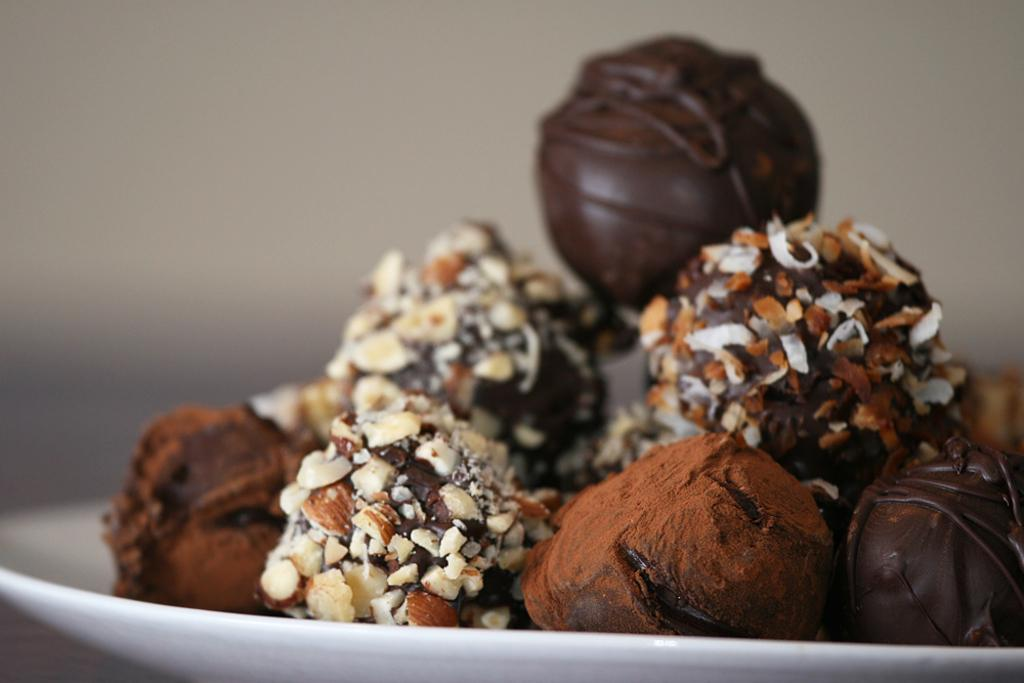What is on the plate that is visible in the image? The plate contains chocolates. What color is the plate in the image? The plate is white. What can be seen in the background of the image? There is a white wall in the background of the image. How is the background of the image depicted? The background of the image is blurred. What type of lace is draped over the chocolates in the image? There is no lace present in the image; the chocolates are on a white plate. How much sugar is sprinkled on the chocolates in the image? There is no sugar visible on the chocolates in the image. 